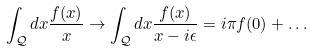Convert formula to latex. <formula><loc_0><loc_0><loc_500><loc_500>\int _ { \mathcal { Q } } d x \frac { f ( x ) } { x } \to \int _ { \mathcal { Q } } d x \frac { f ( x ) } { x - i \epsilon } = i \pi f ( 0 ) + \dots</formula> 